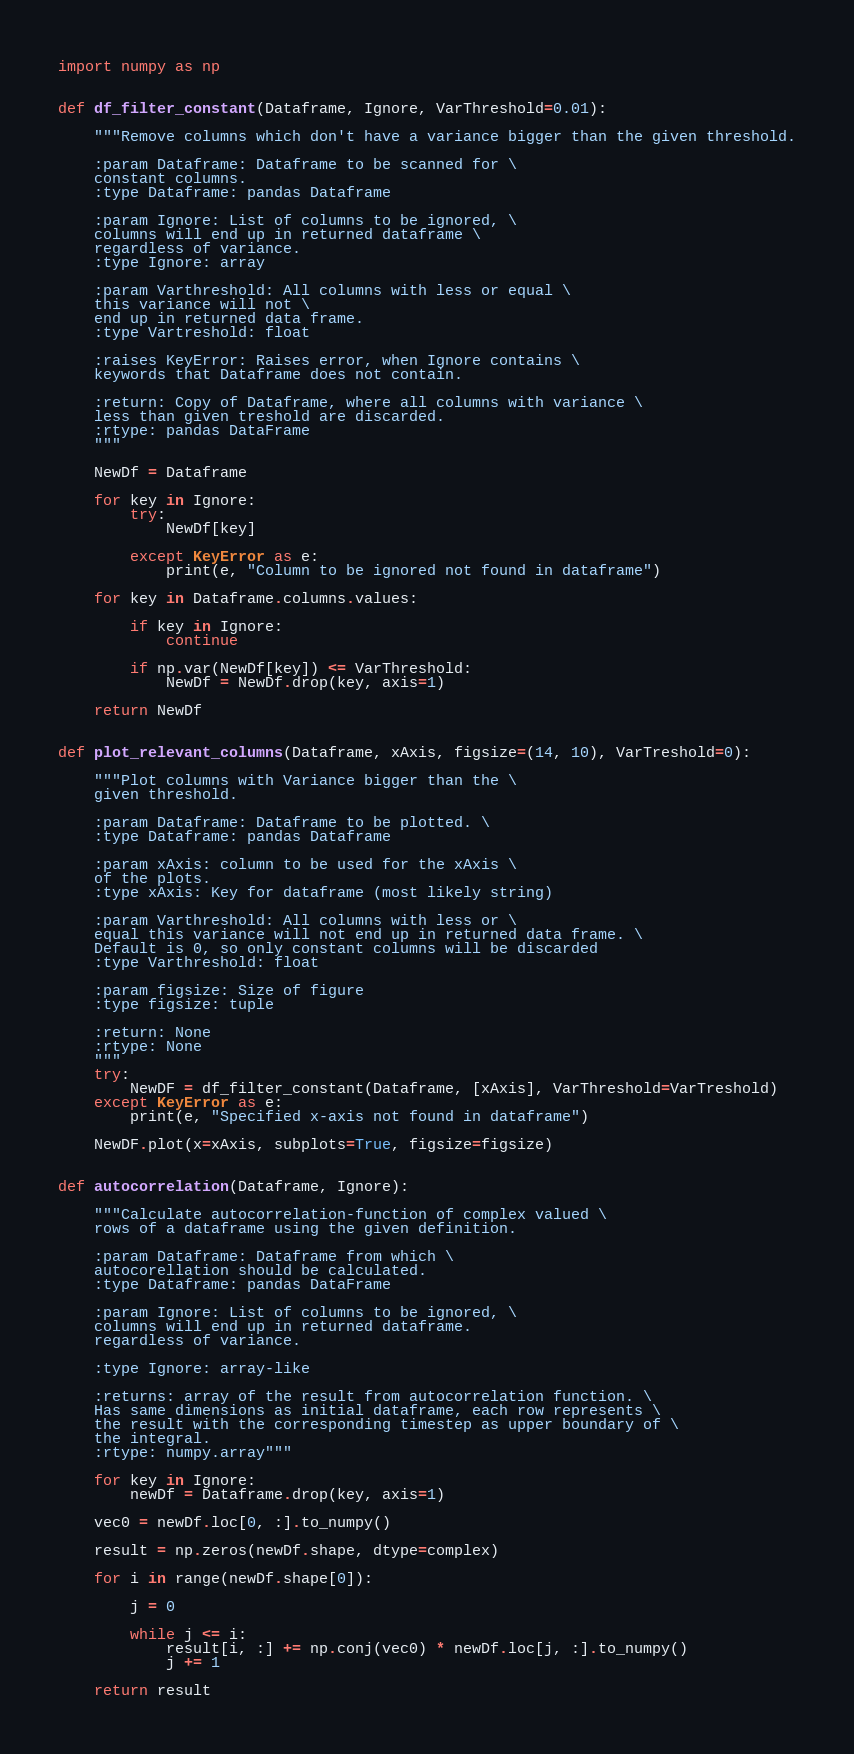Convert code to text. <code><loc_0><loc_0><loc_500><loc_500><_Python_>import numpy as np


def df_filter_constant(Dataframe, Ignore, VarThreshold=0.01):

    """Remove columns which don't have a variance bigger than the given threshold.

    :param Dataframe: Dataframe to be scanned for \
    constant columns.
    :type Dataframe: pandas Dataframe

    :param Ignore: List of columns to be ignored, \
    columns will end up in returned dataframe \
    regardless of variance.
    :type Ignore: array

    :param Varthreshold: All columns with less or equal \
    this variance will not \
    end up in returned data frame.
    :type Vartreshold: float

    :raises KeyError: Raises error, when Ignore contains \
    keywords that Dataframe does not contain.

    :return: Copy of Dataframe, where all columns with variance \
    less than given treshold are discarded.
    :rtype: pandas DataFrame
    """

    NewDf = Dataframe

    for key in Ignore:
        try:
            NewDf[key]

        except KeyError as e:
            print(e, "Column to be ignored not found in dataframe")

    for key in Dataframe.columns.values:

        if key in Ignore:
            continue

        if np.var(NewDf[key]) <= VarThreshold:
            NewDf = NewDf.drop(key, axis=1)

    return NewDf


def plot_relevant_columns(Dataframe, xAxis, figsize=(14, 10), VarTreshold=0):

    """Plot columns with Variance bigger than the \
    given threshold.

    :param Dataframe: Dataframe to be plotted. \
    :type Dataframe: pandas Dataframe

    :param xAxis: column to be used for the xAxis \
    of the plots.
    :type xAxis: Key for dataframe (most likely string)

    :param Varthreshold: All columns with less or \
    equal this variance will not end up in returned data frame. \
    Default is 0, so only constant columns will be discarded
    :type Varthreshold: float

    :param figsize: Size of figure
    :type figsize: tuple

    :return: None
    :rtype: None
    """
    try:
        NewDF = df_filter_constant(Dataframe, [xAxis], VarThreshold=VarTreshold)
    except KeyError as e:
        print(e, "Specified x-axis not found in dataframe")

    NewDF.plot(x=xAxis, subplots=True, figsize=figsize)


def autocorrelation(Dataframe, Ignore):

    """Calculate autocorrelation-function of complex valued \
    rows of a dataframe using the given definition.

    :param Dataframe: Dataframe from which \
    autocorellation should be calculated.
    :type Dataframe: pandas DataFrame

    :param Ignore: List of columns to be ignored, \
    columns will end up in returned dataframe.
    regardless of variance.

    :type Ignore: array-like

    :returns: array of the result from autocorrelation function. \
    Has same dimensions as initial dataframe, each row represents \
    the result with the corresponding timestep as upper boundary of \
    the integral.
    :rtype: numpy.array"""

    for key in Ignore:
        newDf = Dataframe.drop(key, axis=1)

    vec0 = newDf.loc[0, :].to_numpy()

    result = np.zeros(newDf.shape, dtype=complex)

    for i in range(newDf.shape[0]):

        j = 0

        while j <= i:
            result[i, :] += np.conj(vec0) * newDf.loc[j, :].to_numpy()
            j += 1

    return result
</code> 